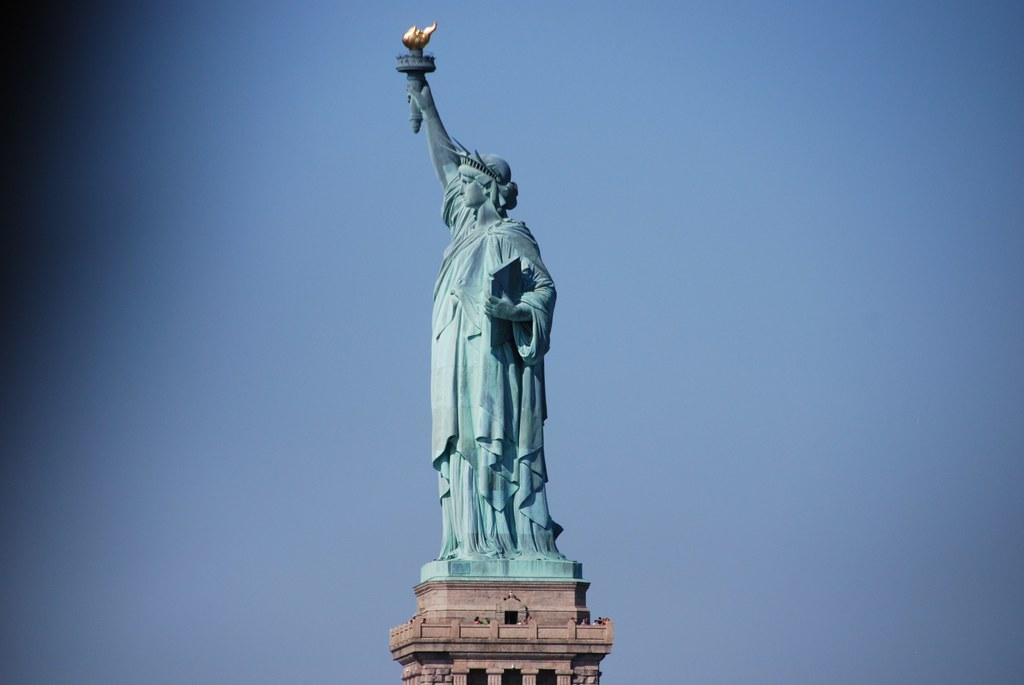What is the main subject of the image? There is a statue of liberty in the image. Where is the statue located? The statue is on a platform. What can be seen in the background of the image? The sky is visible in the background of the image. Can you describe the lighting in the image? The left top corner of the image is dark. How many bees are sitting on the spoon in the image? There is no spoon or bees present in the image. What type of request is being made by the statue in the image? The statue is a non-living object and cannot make requests. 